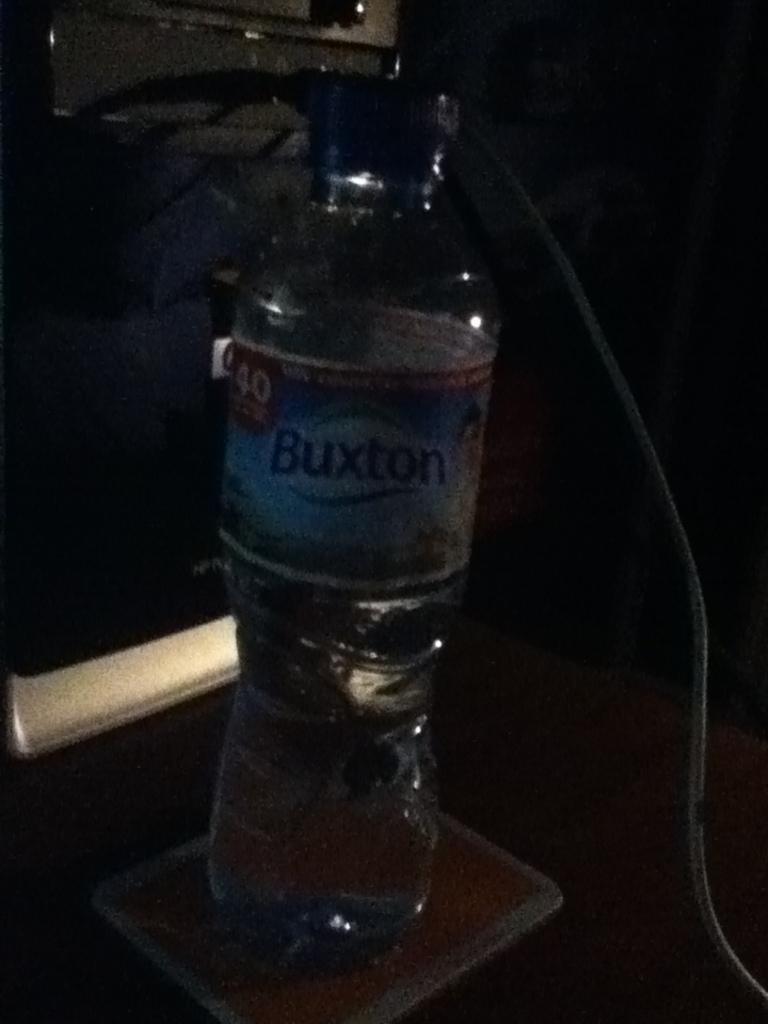What brand name is on the label of the water bottle?
Your answer should be compact. Buxton. What is the number on the top left of the label?
Provide a succinct answer. 40. 